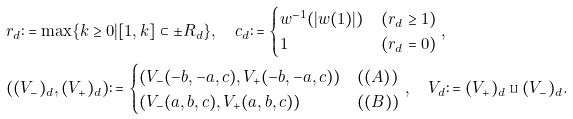<formula> <loc_0><loc_0><loc_500><loc_500>& r _ { d } \colon = \max \{ k \geq 0 | [ 1 , k ] \subset \pm R _ { d } \} , \quad c _ { d } \colon = \begin{cases} w ^ { - 1 } ( | w ( 1 ) | ) & ( r _ { d } \geq 1 ) \\ 1 & ( r _ { d } = 0 ) \end{cases} , \\ & ( ( V _ { - } ) _ { d } , ( V _ { + } ) _ { d } ) \colon = \begin{cases} ( V _ { - } ( - b , - a , c ) , V _ { + } ( - b , - a , c ) ) & ( ( A ) ) \\ ( V _ { - } ( a , b , c ) , V _ { + } ( a , b , c ) ) & ( ( B ) ) \\ \end{cases} , \quad V _ { d } \colon = ( V _ { + } ) _ { d } \amalg ( V _ { - } ) _ { d } .</formula> 